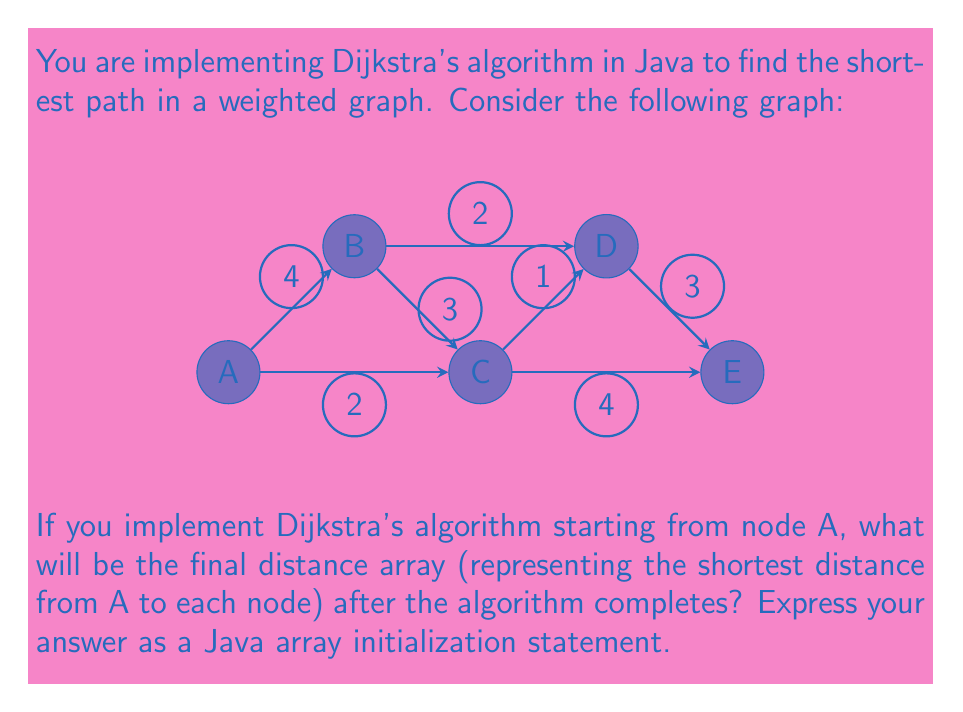Help me with this question. To solve this problem using Dijkstra's algorithm, we'll follow these steps:

1) Initialize the distance array with infinity for all nodes except the start node (A), which has a distance of 0.
   $$ distances = [\infty, \infty, \infty, \infty, \infty] $$
   $$ distances[A] = 0 $$

2) Create a priority queue (or min-heap) with all nodes, prioritized by their current distance.

3) While the priority queue is not empty:
   a) Extract the node with the minimum distance (call it current)
   b) For each neighbor of current:
      - Calculate tentative distance = distance[current] + edge_weight(current, neighbor)
      - If tentative distance < distance[neighbor], update distance[neighbor]

4) Repeat step 3 until the priority queue is empty.

Let's run through the algorithm:

- Start with A: distance[A] = 0
  Update neighbors: B (4), C (2)
  $$ distances = [0, 4, 2, \infty, \infty] $$

- Next node is C (smallest distance)
  Update neighbors: D (2+1=3), E (2+4=6)
  $$ distances = [0, 4, 2, 3, 6] $$

- Next node is B (distance 4)
  Update neighbors: D (4+2=6, no improvement)
  $$ distances = [0, 4, 2, 3, 6] $$

- Next node is D (distance 3)
  Update neighbors: E (3+3=6, no improvement)
  $$ distances = [0, 4, 2, 3, 6] $$

- Finally, E (distance 6)
  No updates needed

The final distance array remains $[0, 4, 2, 3, 6]$.

In Java, we typically use integers to represent infinity in graph algorithms. A common practice is to use Integer.MAX_VALUE. Therefore, the Java array initialization statement would use this value for unreachable nodes, but in this case, all nodes are reachable.
Answer: int[] distances = {0, 4, 2, 3, 6}; 